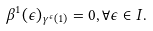Convert formula to latex. <formula><loc_0><loc_0><loc_500><loc_500>\beta ^ { 1 } ( \epsilon ) _ { \gamma ^ { \epsilon } ( 1 ) } = 0 , \forall \epsilon \in I .</formula> 